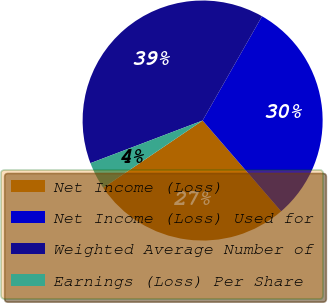<chart> <loc_0><loc_0><loc_500><loc_500><pie_chart><fcel>Net Income (Loss)<fcel>Net Income (Loss) Used for<fcel>Weighted Average Number of<fcel>Earnings (Loss) Per Share<nl><fcel>26.88%<fcel>30.41%<fcel>39.03%<fcel>3.69%<nl></chart> 